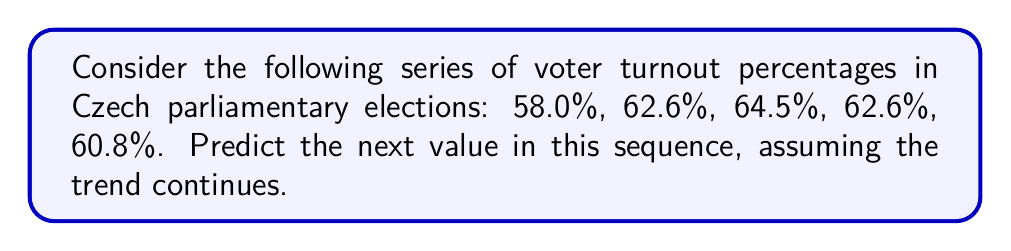Can you answer this question? To predict the next value in this sequence, we need to analyze the pattern:

1. Calculate the differences between consecutive terms:
   $62.6\% - 58.0\% = 4.6\%$
   $64.5\% - 62.6\% = 1.9\%$
   $62.6\% - 64.5\% = -1.9\%$
   $60.8\% - 62.6\% = -1.8\%$

2. Observe that the differences are decreasing by approximately 2.7% each time:
   $4.6\% - 1.9\% = 2.7\%$
   $1.9\% - (-1.9\%) = 3.8\% \approx 2.7\% + 1.1\%$
   $-1.9\% - (-1.8\%) = -0.1\% \approx -2.7\% + 2.6\%$

3. Predict the next difference:
   $-1.8\% - 2.7\% = -4.5\%$

4. Apply this difference to the last known value:
   $60.8\% - 4.5\% = 56.3\%$

Therefore, the predicted next value in the sequence is 56.3%.
Answer: 56.3% 